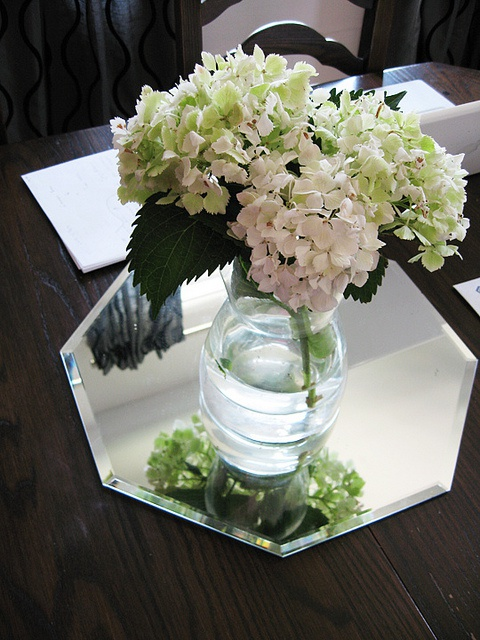Describe the objects in this image and their specific colors. I can see dining table in black, lightgray, darkgray, and olive tones, vase in black, lightgray, darkgray, lightblue, and gray tones, and chair in black, white, gray, and darkgray tones in this image. 